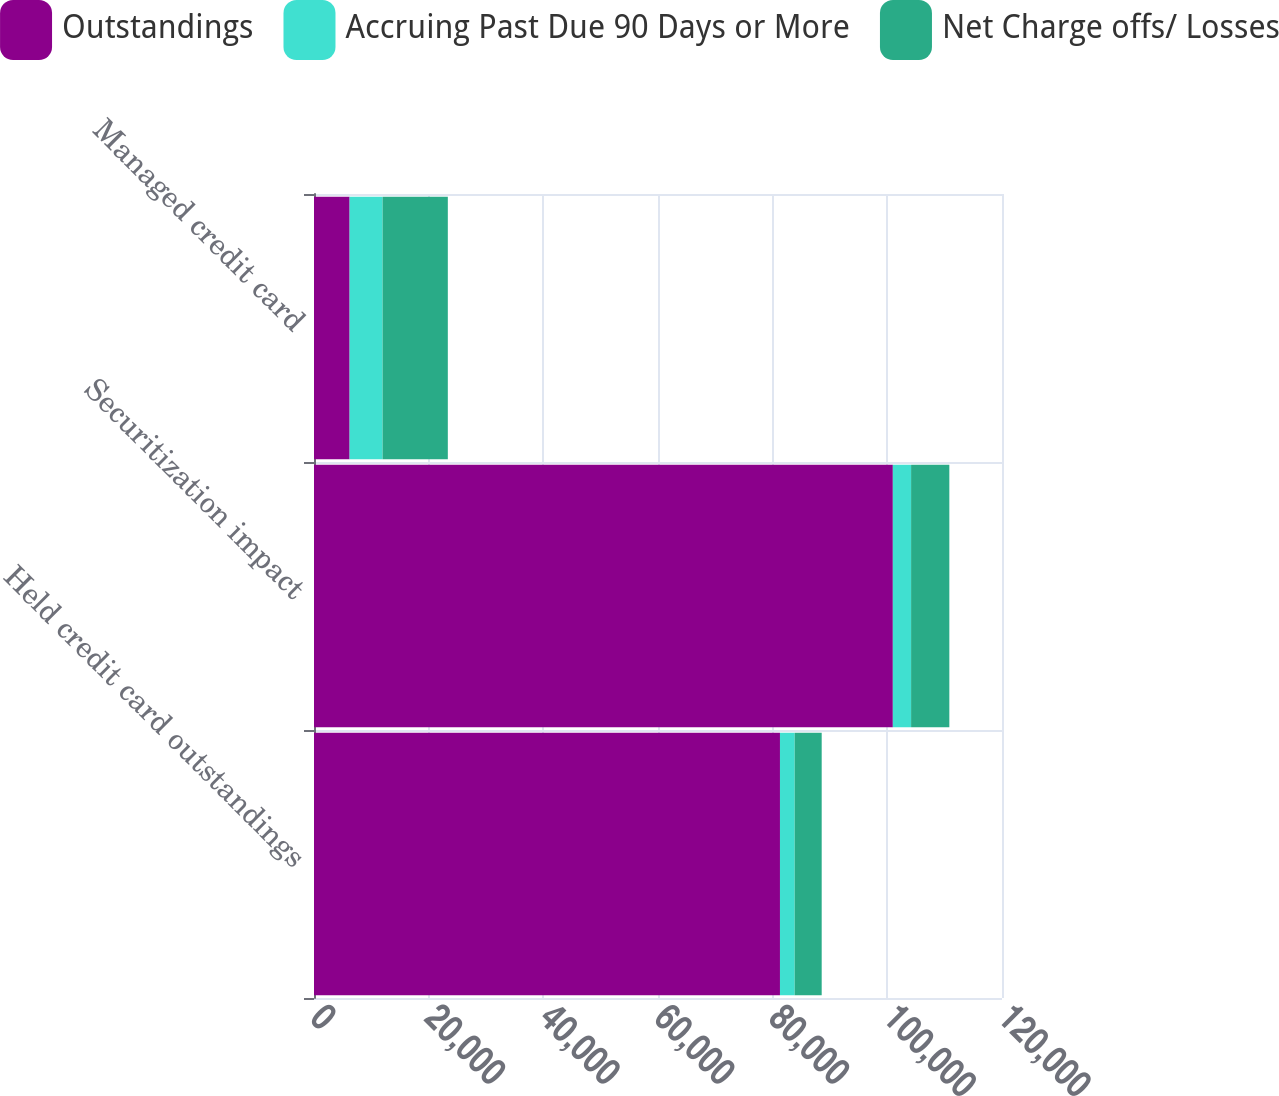<chart> <loc_0><loc_0><loc_500><loc_500><stacked_bar_chart><ecel><fcel>Held credit card outstandings<fcel>Securitization impact<fcel>Managed credit card<nl><fcel>Outstandings<fcel>81274<fcel>100960<fcel>6210<nl><fcel>Accruing Past Due 90 Days or More<fcel>2565<fcel>3185<fcel>5750<nl><fcel>Net Charge offs/ Losses<fcel>4712<fcel>6670<fcel>11382<nl></chart> 